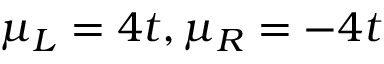Convert formula to latex. <formula><loc_0><loc_0><loc_500><loc_500>\mu _ { L } = 4 t , \mu _ { R } = - 4 t</formula> 